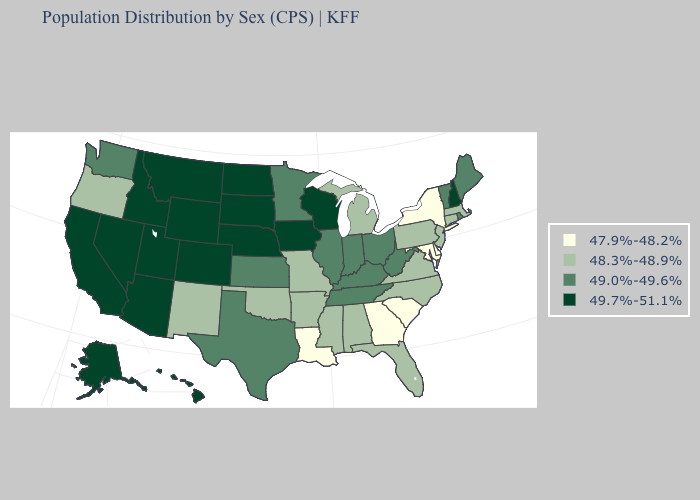What is the value of Ohio?
Concise answer only. 49.0%-49.6%. Among the states that border Vermont , does Massachusetts have the highest value?
Short answer required. No. Does Montana have the highest value in the USA?
Keep it brief. Yes. What is the value of Arkansas?
Concise answer only. 48.3%-48.9%. Name the states that have a value in the range 48.3%-48.9%?
Give a very brief answer. Alabama, Arkansas, Connecticut, Florida, Massachusetts, Michigan, Mississippi, Missouri, New Jersey, New Mexico, North Carolina, Oklahoma, Oregon, Pennsylvania, Virginia. What is the highest value in states that border Michigan?
Write a very short answer. 49.7%-51.1%. Name the states that have a value in the range 48.3%-48.9%?
Be succinct. Alabama, Arkansas, Connecticut, Florida, Massachusetts, Michigan, Mississippi, Missouri, New Jersey, New Mexico, North Carolina, Oklahoma, Oregon, Pennsylvania, Virginia. Name the states that have a value in the range 49.0%-49.6%?
Be succinct. Illinois, Indiana, Kansas, Kentucky, Maine, Minnesota, Ohio, Rhode Island, Tennessee, Texas, Vermont, Washington, West Virginia. What is the value of Utah?
Write a very short answer. 49.7%-51.1%. What is the value of North Carolina?
Quick response, please. 48.3%-48.9%. Does Michigan have a higher value than Georgia?
Be succinct. Yes. What is the lowest value in the West?
Keep it brief. 48.3%-48.9%. Does Alaska have a higher value than Utah?
Short answer required. No. Name the states that have a value in the range 47.9%-48.2%?
Be succinct. Delaware, Georgia, Louisiana, Maryland, New York, South Carolina. Among the states that border New Mexico , which have the lowest value?
Concise answer only. Oklahoma. 